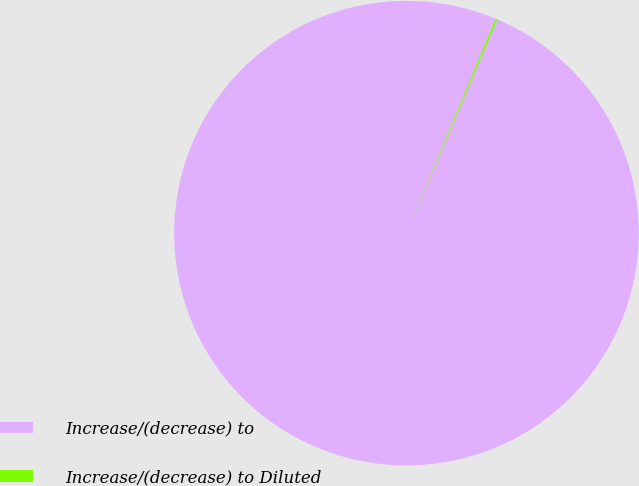Convert chart to OTSL. <chart><loc_0><loc_0><loc_500><loc_500><pie_chart><fcel>Increase/(decrease) to<fcel>Increase/(decrease) to Diluted<nl><fcel>99.86%<fcel>0.14%<nl></chart> 